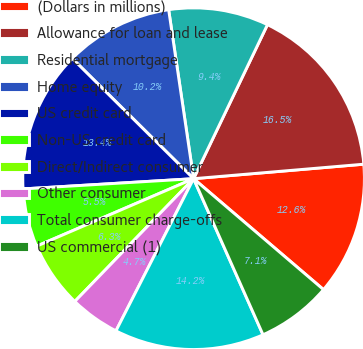Convert chart to OTSL. <chart><loc_0><loc_0><loc_500><loc_500><pie_chart><fcel>(Dollars in millions)<fcel>Allowance for loan and lease<fcel>Residential mortgage<fcel>Home equity<fcel>US credit card<fcel>Non-US credit card<fcel>Direct/Indirect consumer<fcel>Other consumer<fcel>Total consumer charge-offs<fcel>US commercial (1)<nl><fcel>12.6%<fcel>16.53%<fcel>9.45%<fcel>10.24%<fcel>13.38%<fcel>5.51%<fcel>6.3%<fcel>4.73%<fcel>14.17%<fcel>7.09%<nl></chart> 